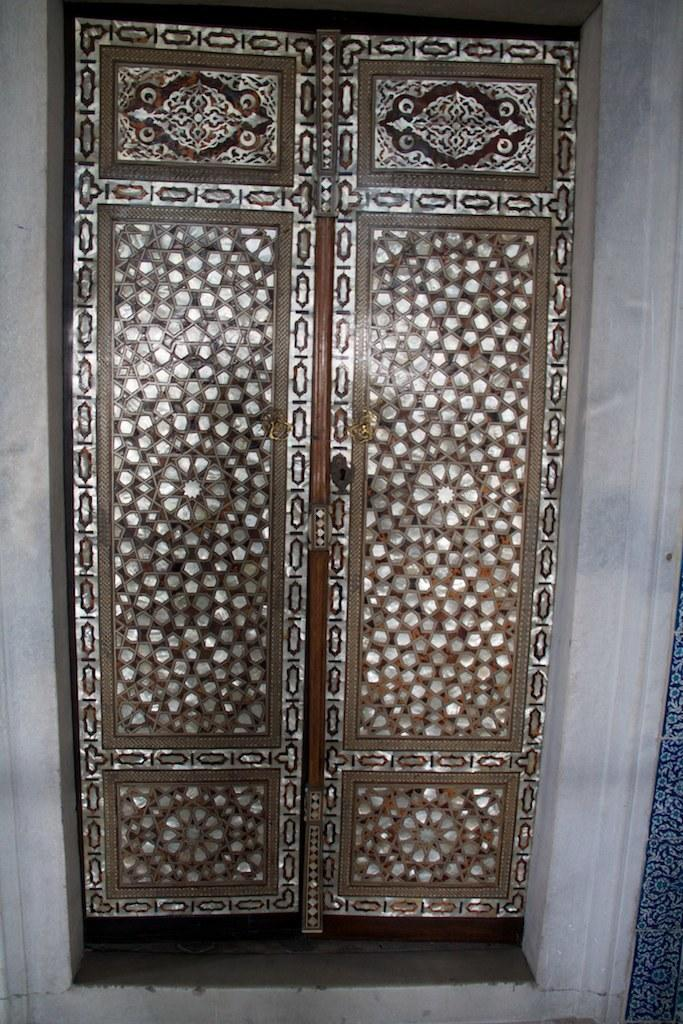What type of architectural feature can be seen in the image? There are doors and a wall in the image. Can you describe the object on the right side of the image? Unfortunately, the provided facts do not give any information about the object on the right side of the image. What type of produce is being flavored by the tramp in the image? There is no produce, flavor, or tramp present in the image. 